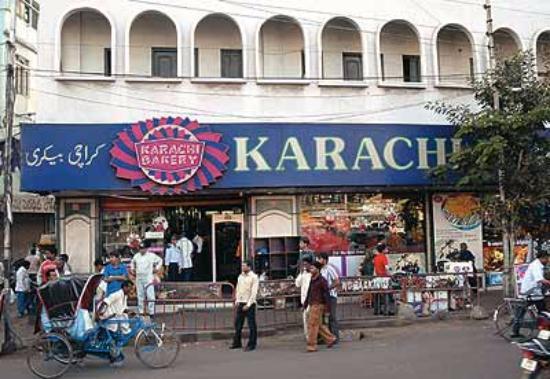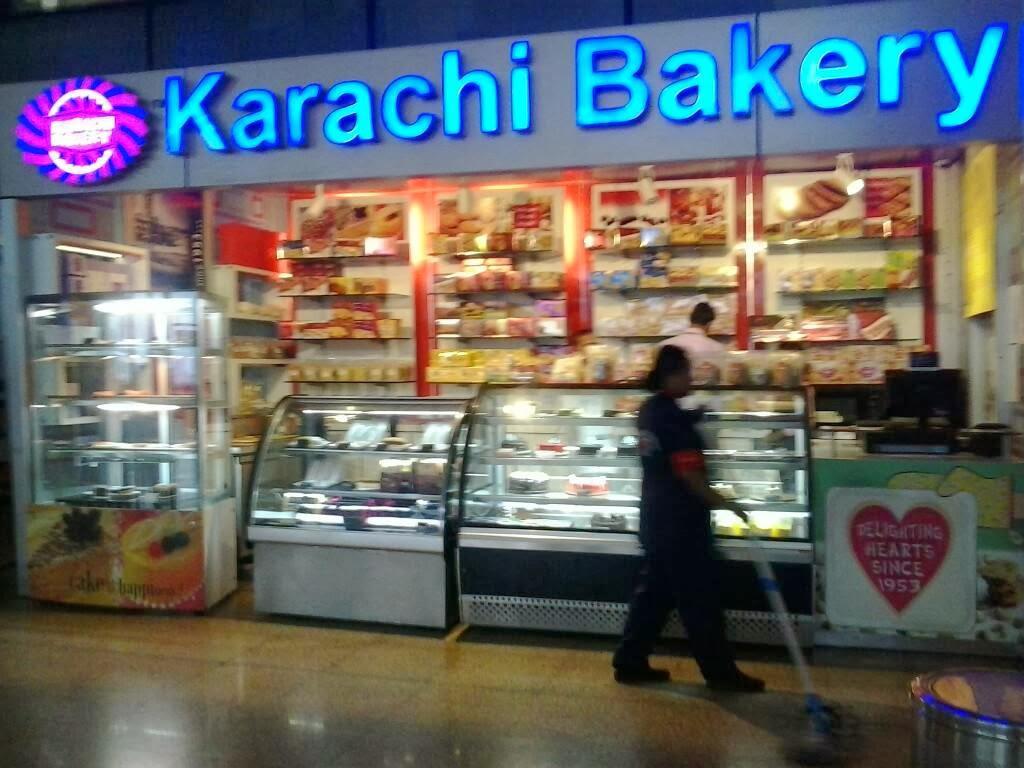The first image is the image on the left, the second image is the image on the right. Evaluate the accuracy of this statement regarding the images: "There is at least one person in front of a store in the right image.". Is it true? Answer yes or no. Yes. The first image is the image on the left, the second image is the image on the right. Assess this claim about the two images: "There is a four tier desert case that houses cholate desserts and breads.". Correct or not? Answer yes or no. No. 